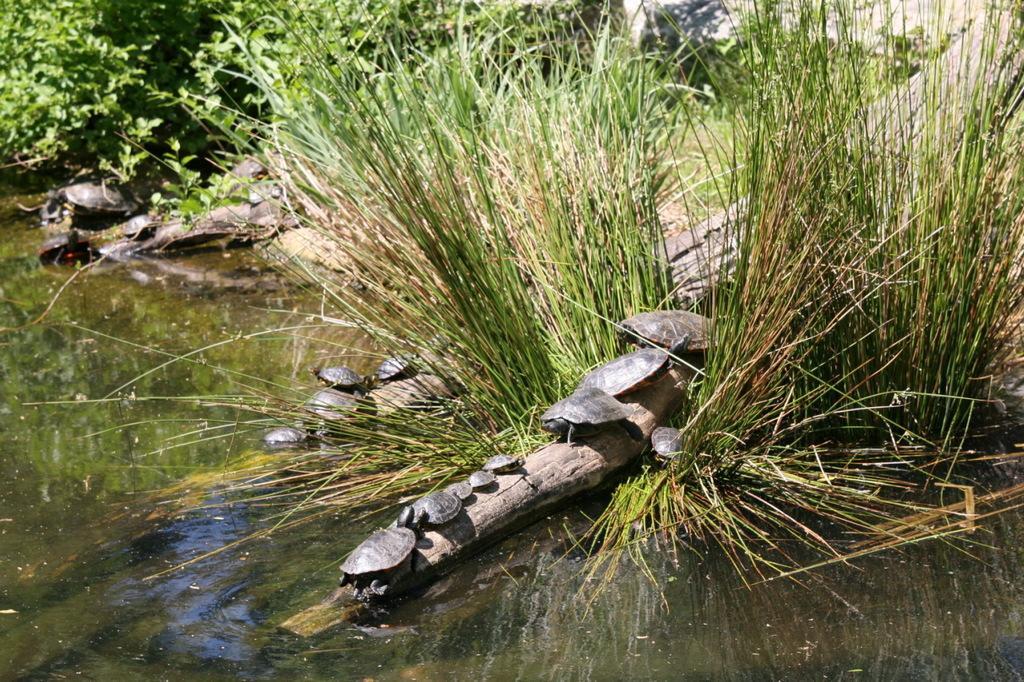Can you describe this image briefly? This picture is clicked outside. In the foreground we can see a water body and we can see the turtles on a bamboo and we can see the grass and plants and some objects. 